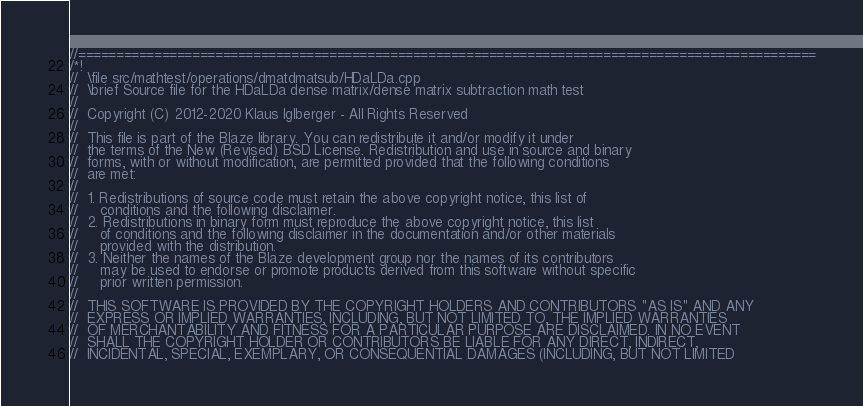<code> <loc_0><loc_0><loc_500><loc_500><_C++_>//=================================================================================================
/*!
//  \file src/mathtest/operations/dmatdmatsub/HDaLDa.cpp
//  \brief Source file for the HDaLDa dense matrix/dense matrix subtraction math test
//
//  Copyright (C) 2012-2020 Klaus Iglberger - All Rights Reserved
//
//  This file is part of the Blaze library. You can redistribute it and/or modify it under
//  the terms of the New (Revised) BSD License. Redistribution and use in source and binary
//  forms, with or without modification, are permitted provided that the following conditions
//  are met:
//
//  1. Redistributions of source code must retain the above copyright notice, this list of
//     conditions and the following disclaimer.
//  2. Redistributions in binary form must reproduce the above copyright notice, this list
//     of conditions and the following disclaimer in the documentation and/or other materials
//     provided with the distribution.
//  3. Neither the names of the Blaze development group nor the names of its contributors
//     may be used to endorse or promote products derived from this software without specific
//     prior written permission.
//
//  THIS SOFTWARE IS PROVIDED BY THE COPYRIGHT HOLDERS AND CONTRIBUTORS "AS IS" AND ANY
//  EXPRESS OR IMPLIED WARRANTIES, INCLUDING, BUT NOT LIMITED TO, THE IMPLIED WARRANTIES
//  OF MERCHANTABILITY AND FITNESS FOR A PARTICULAR PURPOSE ARE DISCLAIMED. IN NO EVENT
//  SHALL THE COPYRIGHT HOLDER OR CONTRIBUTORS BE LIABLE FOR ANY DIRECT, INDIRECT,
//  INCIDENTAL, SPECIAL, EXEMPLARY, OR CONSEQUENTIAL DAMAGES (INCLUDING, BUT NOT LIMITED</code> 